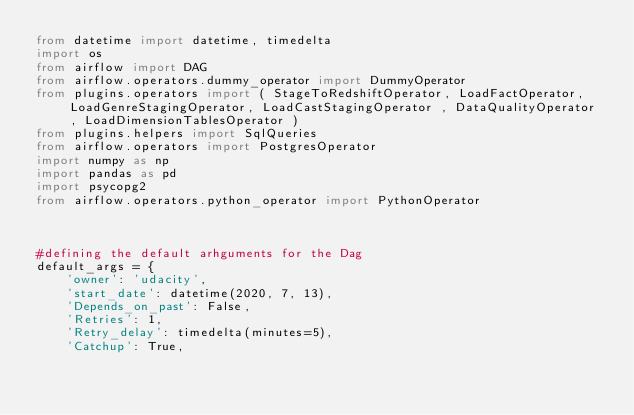Convert code to text. <code><loc_0><loc_0><loc_500><loc_500><_Python_>from datetime import datetime, timedelta
import os
from airflow import DAG
from airflow.operators.dummy_operator import DummyOperator
from plugins.operators import ( StageToRedshiftOperator, LoadFactOperator, LoadGenreStagingOperator, LoadCastStagingOperator , DataQualityOperator , LoadDimensionTablesOperator )      
from plugins.helpers import SqlQueries
from airflow.operators import PostgresOperator
import numpy as np
import pandas as pd
import psycopg2
from airflow.operators.python_operator import PythonOperator
 


#defining the default arhguments for the Dag
default_args = {
    'owner': 'udacity',
    'start_date': datetime(2020, 7, 13),
    'Depends_on_past': False,
    'Retries': 1,
    'Retry_delay': timedelta(minutes=5),
    'Catchup': True,</code> 